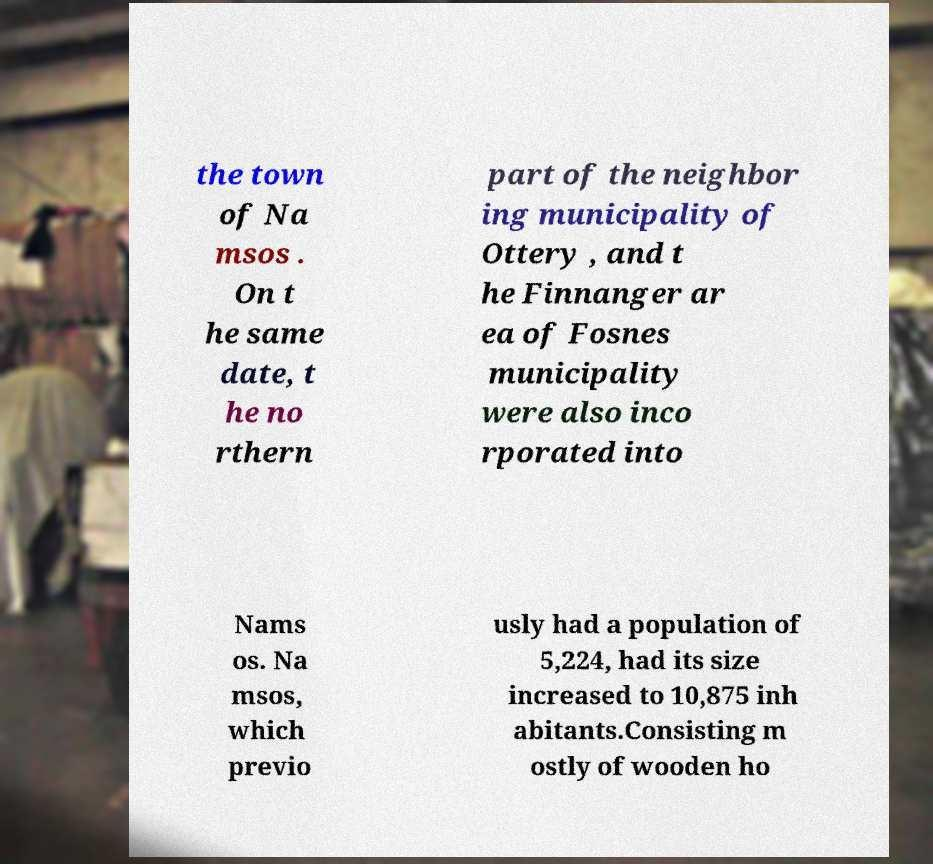Could you assist in decoding the text presented in this image and type it out clearly? the town of Na msos . On t he same date, t he no rthern part of the neighbor ing municipality of Ottery , and t he Finnanger ar ea of Fosnes municipality were also inco rporated into Nams os. Na msos, which previo usly had a population of 5,224, had its size increased to 10,875 inh abitants.Consisting m ostly of wooden ho 